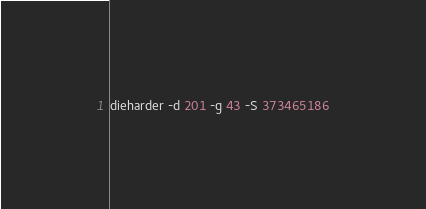Convert code to text. <code><loc_0><loc_0><loc_500><loc_500><_Bash_>dieharder -d 201 -g 43 -S 373465186
</code> 